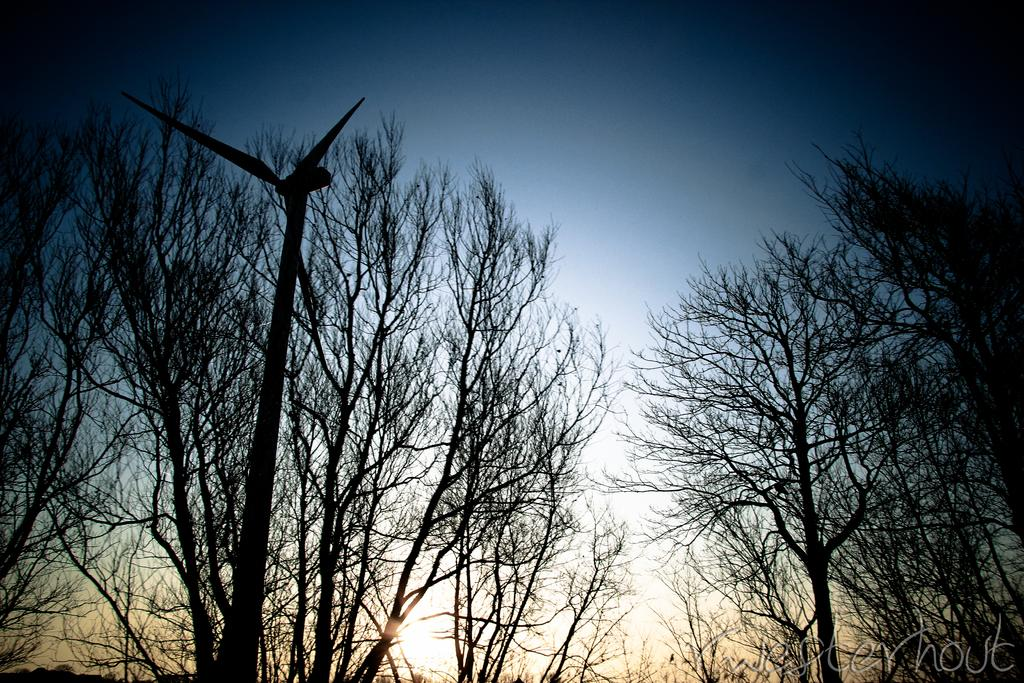What is the main structure in the image? There is a windmill in the image. What can be seen behind the windmill? There are many dry trees behind the windmill. What color is the sky in the background of the image? The sky is blue in the background of the image. What type of toothbrush is the creature using in the image? There is no creature or toothbrush present in the image. 